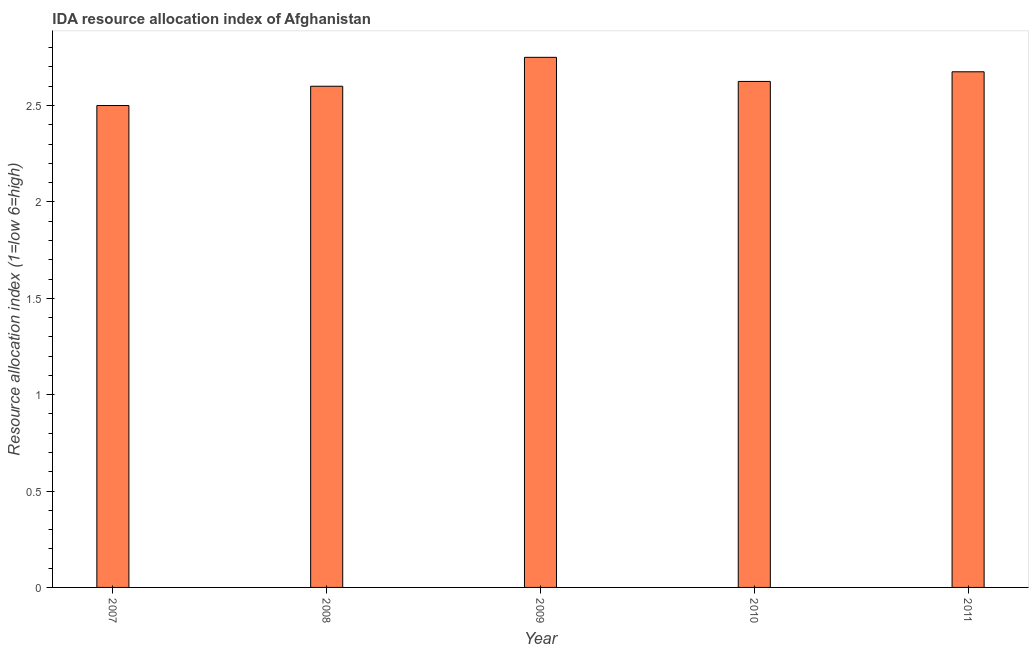Does the graph contain any zero values?
Give a very brief answer. No. What is the title of the graph?
Offer a terse response. IDA resource allocation index of Afghanistan. What is the label or title of the X-axis?
Your response must be concise. Year. What is the label or title of the Y-axis?
Make the answer very short. Resource allocation index (1=low 6=high). What is the ida resource allocation index in 2011?
Give a very brief answer. 2.67. Across all years, what is the maximum ida resource allocation index?
Offer a terse response. 2.75. In which year was the ida resource allocation index maximum?
Your response must be concise. 2009. In which year was the ida resource allocation index minimum?
Make the answer very short. 2007. What is the sum of the ida resource allocation index?
Give a very brief answer. 13.15. What is the average ida resource allocation index per year?
Offer a very short reply. 2.63. What is the median ida resource allocation index?
Offer a terse response. 2.62. What is the ratio of the ida resource allocation index in 2007 to that in 2010?
Make the answer very short. 0.95. What is the difference between the highest and the second highest ida resource allocation index?
Ensure brevity in your answer.  0.07. Are all the bars in the graph horizontal?
Offer a very short reply. No. Are the values on the major ticks of Y-axis written in scientific E-notation?
Make the answer very short. No. What is the Resource allocation index (1=low 6=high) of 2007?
Provide a short and direct response. 2.5. What is the Resource allocation index (1=low 6=high) in 2009?
Give a very brief answer. 2.75. What is the Resource allocation index (1=low 6=high) in 2010?
Your response must be concise. 2.62. What is the Resource allocation index (1=low 6=high) in 2011?
Your answer should be very brief. 2.67. What is the difference between the Resource allocation index (1=low 6=high) in 2007 and 2008?
Give a very brief answer. -0.1. What is the difference between the Resource allocation index (1=low 6=high) in 2007 and 2009?
Offer a terse response. -0.25. What is the difference between the Resource allocation index (1=low 6=high) in 2007 and 2010?
Provide a short and direct response. -0.12. What is the difference between the Resource allocation index (1=low 6=high) in 2007 and 2011?
Offer a terse response. -0.17. What is the difference between the Resource allocation index (1=low 6=high) in 2008 and 2009?
Offer a very short reply. -0.15. What is the difference between the Resource allocation index (1=low 6=high) in 2008 and 2010?
Keep it short and to the point. -0.03. What is the difference between the Resource allocation index (1=low 6=high) in 2008 and 2011?
Your response must be concise. -0.07. What is the difference between the Resource allocation index (1=low 6=high) in 2009 and 2010?
Provide a short and direct response. 0.12. What is the difference between the Resource allocation index (1=low 6=high) in 2009 and 2011?
Your response must be concise. 0.07. What is the difference between the Resource allocation index (1=low 6=high) in 2010 and 2011?
Provide a succinct answer. -0.05. What is the ratio of the Resource allocation index (1=low 6=high) in 2007 to that in 2008?
Ensure brevity in your answer.  0.96. What is the ratio of the Resource allocation index (1=low 6=high) in 2007 to that in 2009?
Provide a succinct answer. 0.91. What is the ratio of the Resource allocation index (1=low 6=high) in 2007 to that in 2011?
Provide a succinct answer. 0.94. What is the ratio of the Resource allocation index (1=low 6=high) in 2008 to that in 2009?
Your response must be concise. 0.94. What is the ratio of the Resource allocation index (1=low 6=high) in 2008 to that in 2011?
Give a very brief answer. 0.97. What is the ratio of the Resource allocation index (1=low 6=high) in 2009 to that in 2010?
Keep it short and to the point. 1.05. What is the ratio of the Resource allocation index (1=low 6=high) in 2009 to that in 2011?
Your response must be concise. 1.03. 